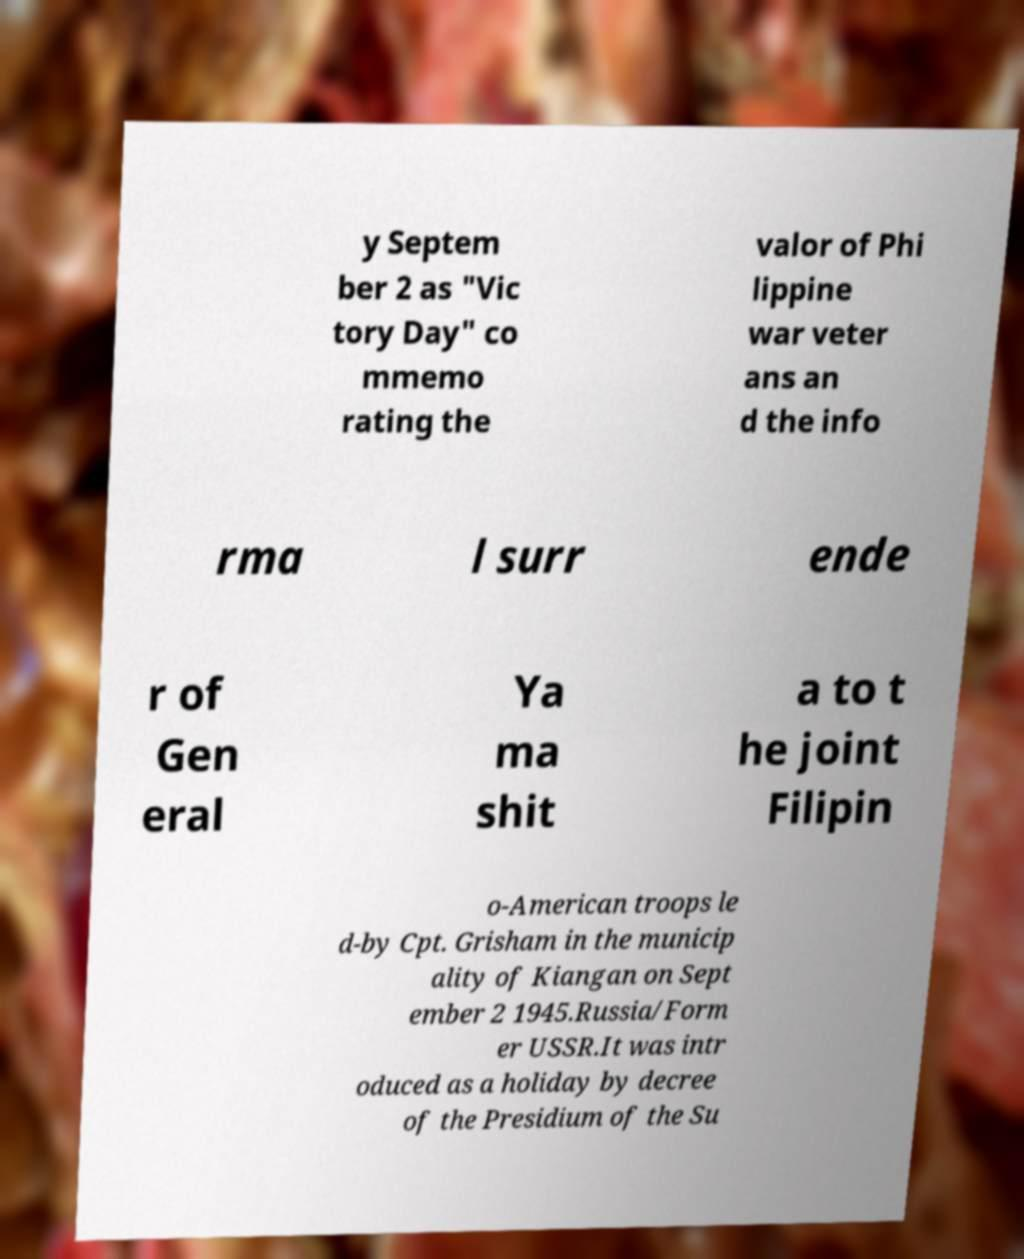For documentation purposes, I need the text within this image transcribed. Could you provide that? y Septem ber 2 as "Vic tory Day" co mmemo rating the valor of Phi lippine war veter ans an d the info rma l surr ende r of Gen eral Ya ma shit a to t he joint Filipin o-American troops le d-by Cpt. Grisham in the municip ality of Kiangan on Sept ember 2 1945.Russia/Form er USSR.It was intr oduced as a holiday by decree of the Presidium of the Su 